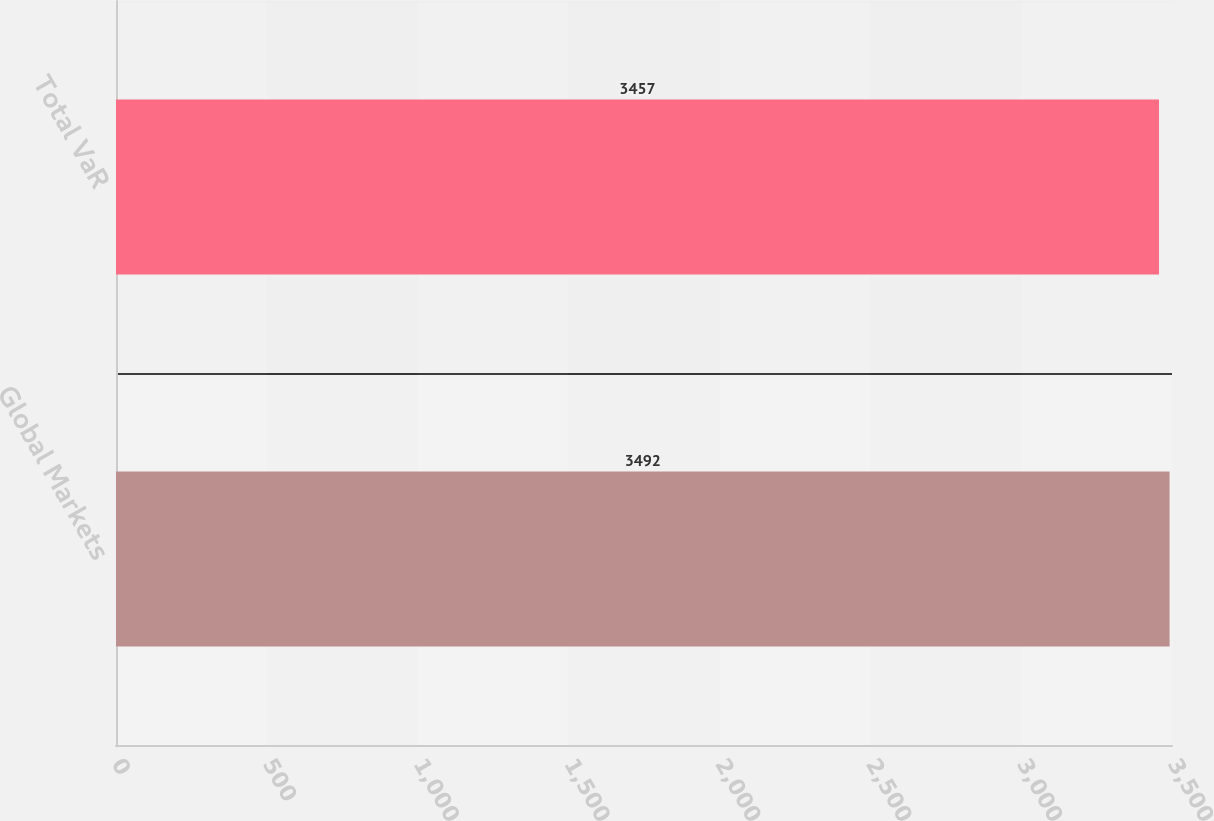Convert chart. <chart><loc_0><loc_0><loc_500><loc_500><bar_chart><fcel>Global Markets<fcel>Total VaR<nl><fcel>3492<fcel>3457<nl></chart> 